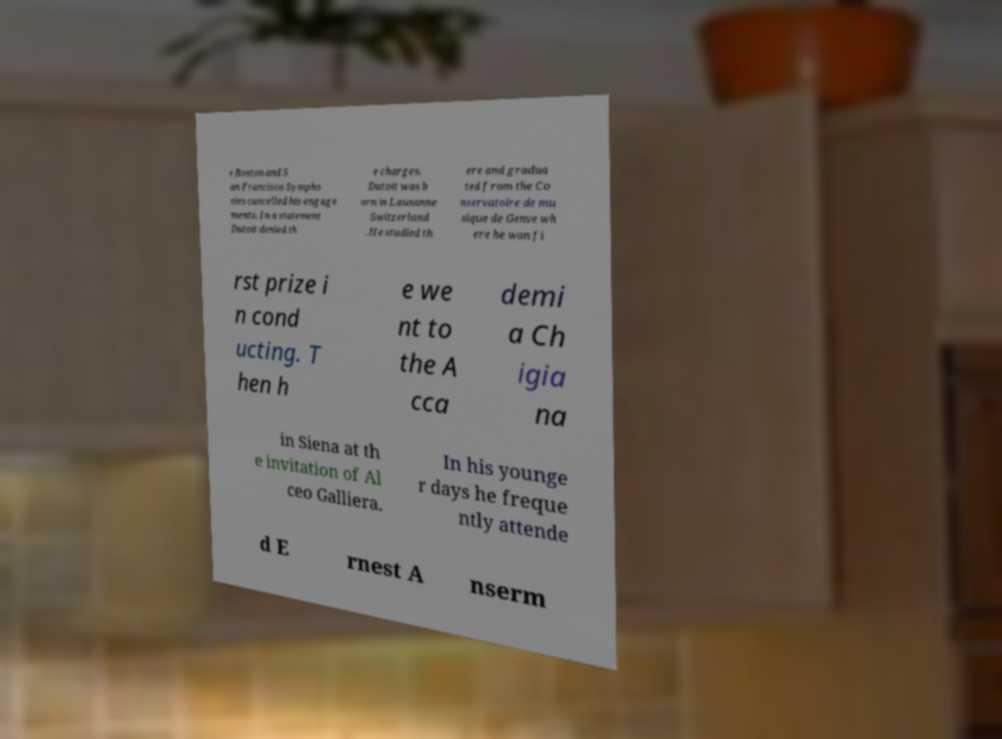Please read and relay the text visible in this image. What does it say? e Boston and S an Francisco Sympho nies cancelled his engage ments. In a statement Dutoit denied th e charges. Dutoit was b orn in Lausanne Switzerland . He studied th ere and gradua ted from the Co nservatoire de mu sique de Genve wh ere he won fi rst prize i n cond ucting. T hen h e we nt to the A cca demi a Ch igia na in Siena at th e invitation of Al ceo Galliera. In his younge r days he freque ntly attende d E rnest A nserm 